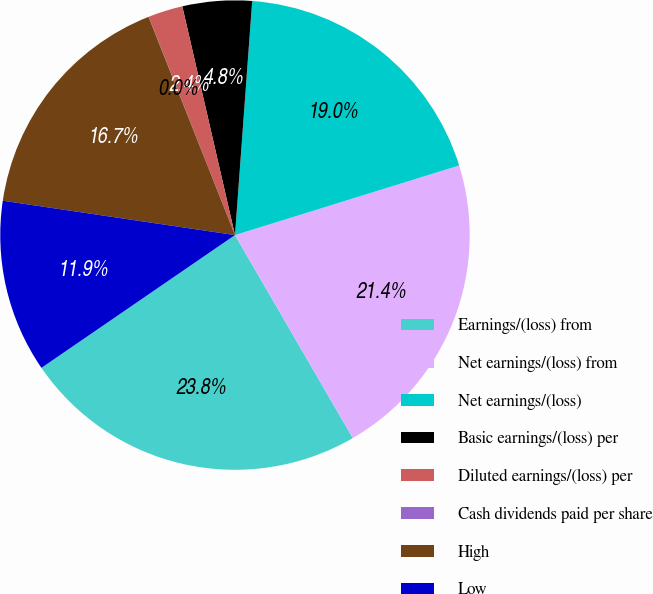Convert chart. <chart><loc_0><loc_0><loc_500><loc_500><pie_chart><fcel>Earnings/(loss) from<fcel>Net earnings/(loss) from<fcel>Net earnings/(loss)<fcel>Basic earnings/(loss) per<fcel>Diluted earnings/(loss) per<fcel>Cash dividends paid per share<fcel>High<fcel>Low<nl><fcel>23.8%<fcel>21.42%<fcel>19.04%<fcel>4.77%<fcel>2.39%<fcel>0.01%<fcel>16.66%<fcel>11.91%<nl></chart> 